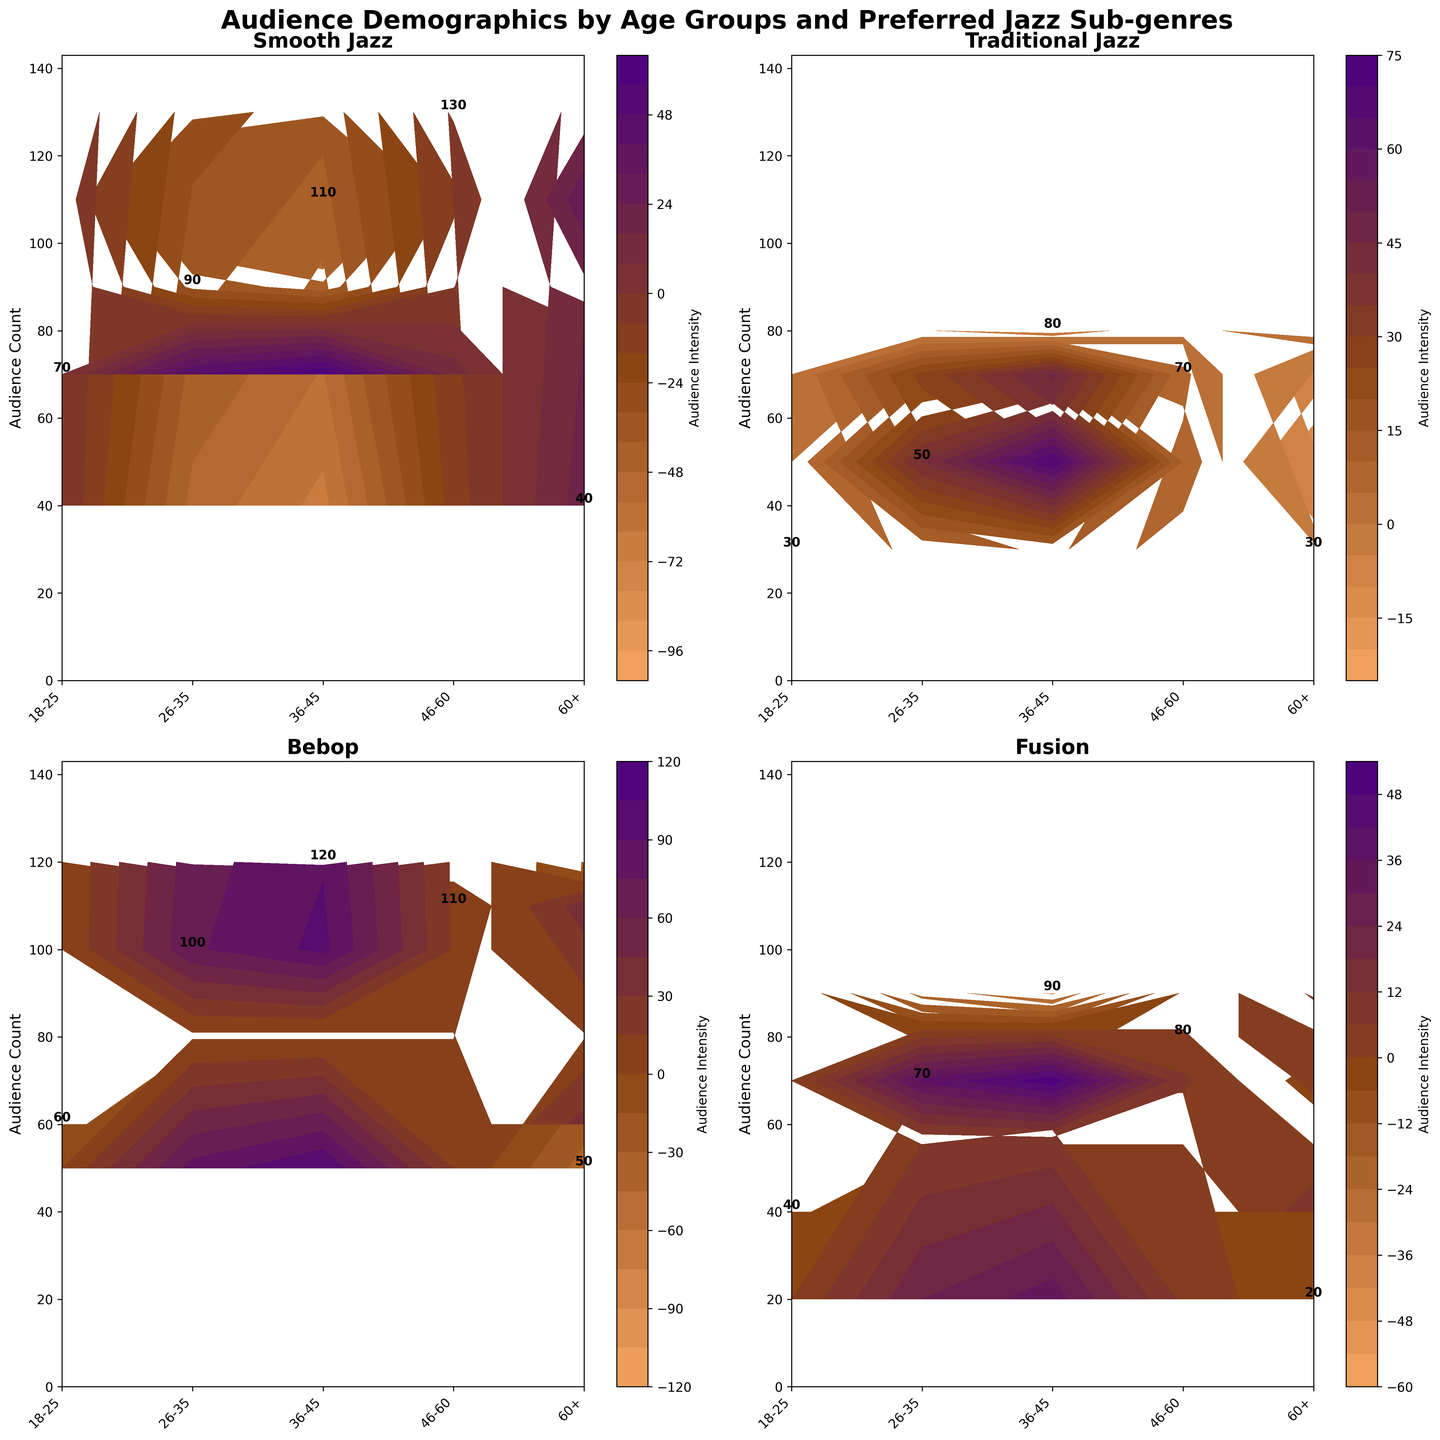What is the title of the figure? The title is typically placed at the top of the figure and is large and bold for easy reading. In this case, the title is written as "Audience Demographics by Age Groups and Preferred Jazz Sub-genres".
Answer: Audience Demographics by Age Groups and Preferred Jazz Sub-genres Which age group has the highest audience count for Bebop? Looking at the subplot for Bebop, we identify the highest count value among the displayed numbers for each age group. The 36-45 age group has the highest count of 120.
Answer: 36-45 How many subplots are shown in the figure? The figure contains four subplots, each representing one jazz subgenre: Smooth Jazz, Traditional Jazz, Bebop, and Fusion.
Answer: 4 What is the count of the 26-35 age group for Smooth Jazz? In the Smooth Jazz subplot, locate the label for the 26-35 age group and identify the count number written near the top of the bar. The count is 90.
Answer: 90 Which jazz subgenre has the lowest audience count for the 60+ age group? By examining each subplot and checking the counts for the 60+ age group, Fusion has the lowest audience count with a value of 20.
Answer: Fusion Comparing the 36-45 and 46-60 age groups, which one prefers Smooth Jazz more? Using the Smooth Jazz subplot, compare the counts for the 36-45 and 46-60 age groups. The counts are 110 and 130, respectively, indicating the 46-60 age group prefers Smooth Jazz more.
Answer: 46-60 What is the average audience count for Traditional Jazz across all age groups? Add the counts for Traditional Jazz across all age groups: 30+50+80+70+30 = 260. Divide by the number of age groups, which is 5. The average count is 260/5 = 52.
Answer: 52 Which subgenre has the most balanced audience count across all age groups? By visually comparing the distributions of counts across age groups in each subplot, Bebop appears to have a relatively balanced distribution with counts of 60, 100, 120, 110, and 50.
Answer: Bebop What is the difference in audience count between the 18-25 and 60+ age groups for Fusion? Find the counts for the two age groups in the Fusion subplot: 40 (18-25) and 20 (60+). The difference is 40 - 20 = 20.
Answer: 20 